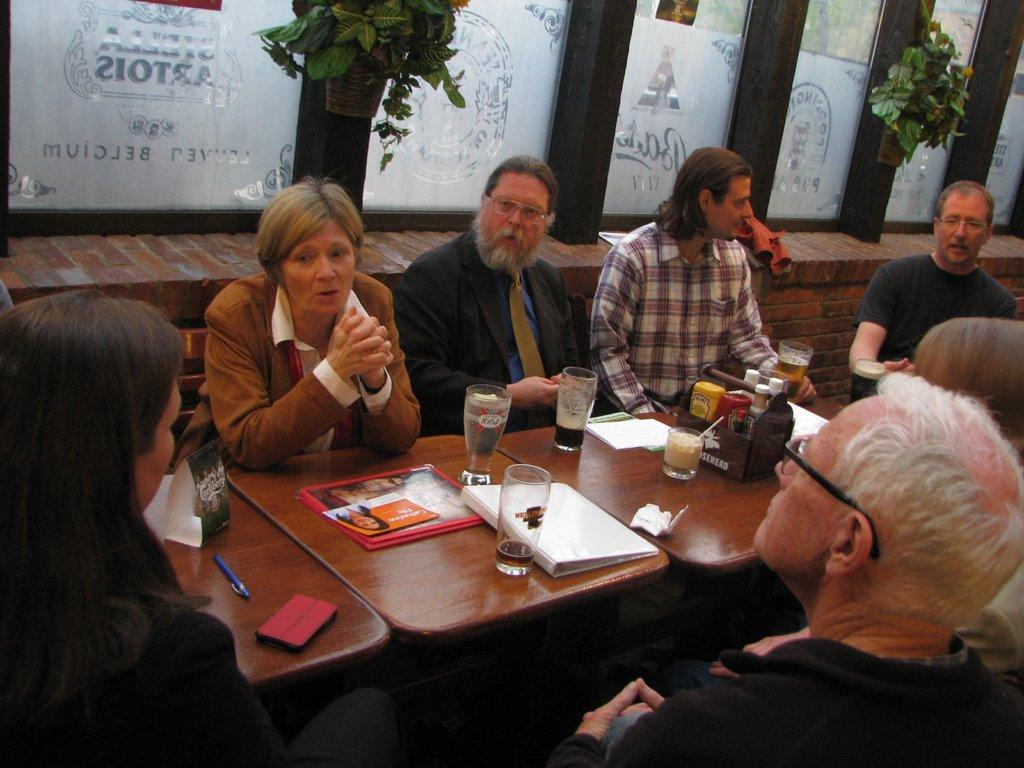What is happening in the image? There is a group of people in the image, and they are sitting around a table. What are the people doing while sitting around the table? The people are talking among themselves. What type of ray is visible in the image? There is no ray present in the image; it features a group of people sitting around a table and talking. 